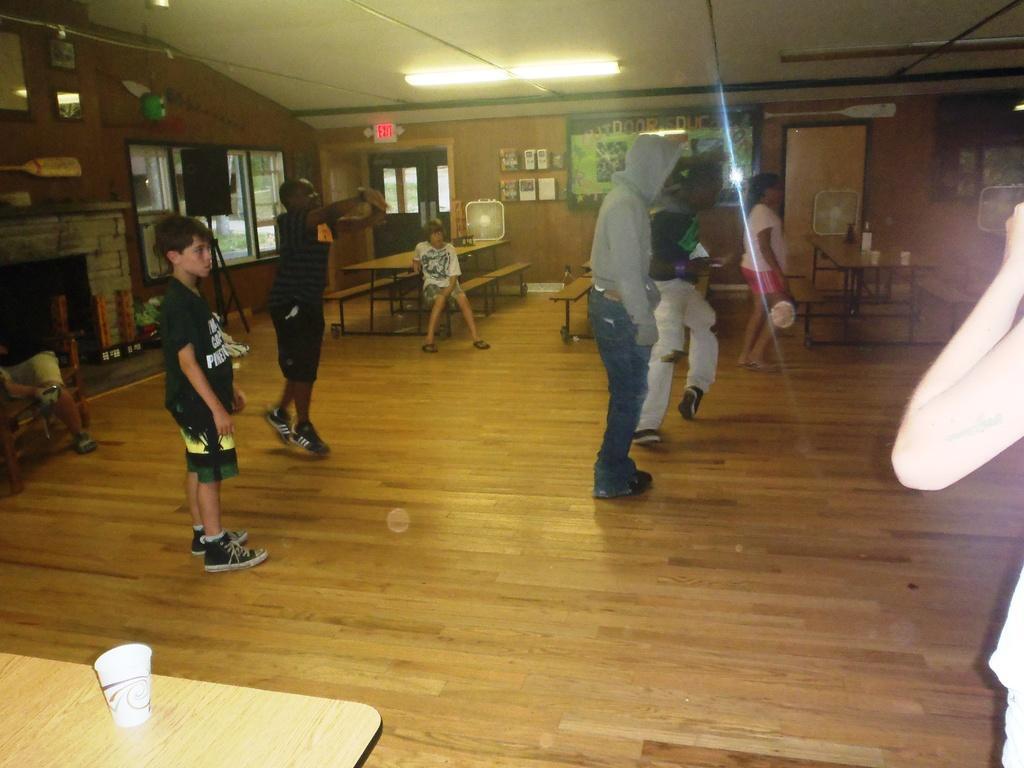Please provide a concise description of this image. In this picture I can see group of people standing, there are some objects on the benches, there are windows, there are frames attached to the walls, there is a tube light, there is a speaker with a stand and there are some other objects. 